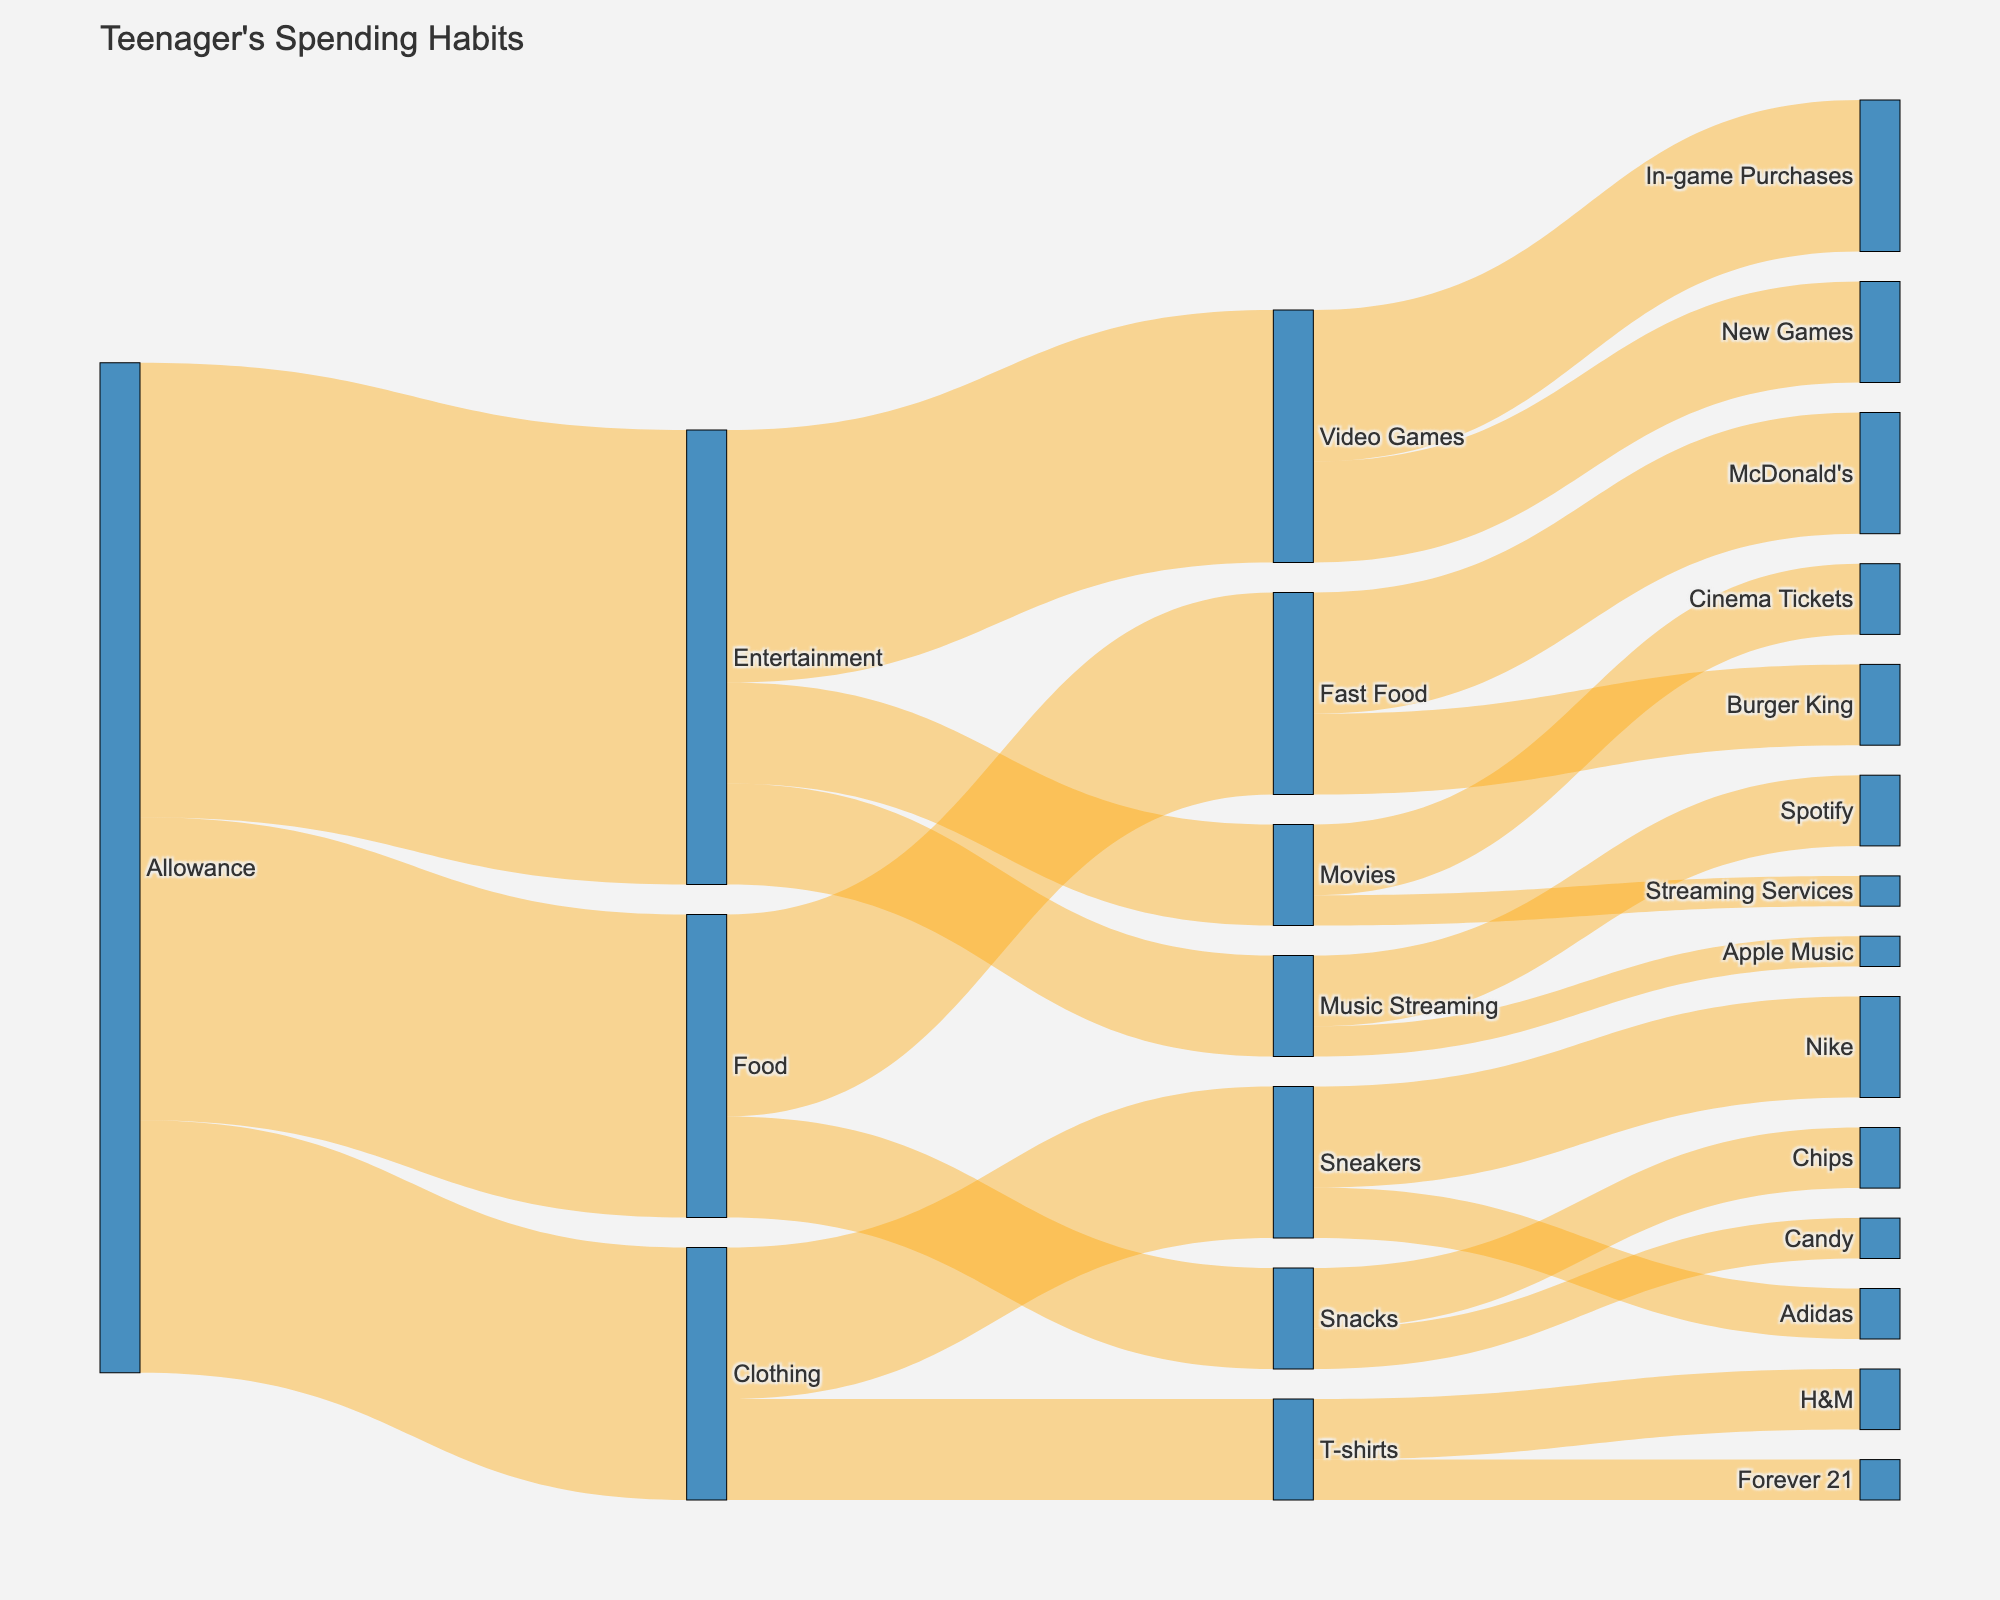what is the largest spending category for teenagers? The largest spending category for teenagers can be determined by the width of the flow connecting the "Allowance" node to the categories. The largest is "Entertainment" with a value of 45.
Answer: Entertainment how much do teenagers spend on video games? To find this, look at the flow from "Entertainment" to "Video Games," which has a value of 25.
Answer: 25 which fast food chain gets more money from teenagers, McDonald's or Burger King? Compare the widths of the flows from "Fast Food" to "McDonald's" and "Burger King." "McDonald's" has a value of 12 and "Burger King" has a value of 8.
Answer: McDonald's what is the total amount spent on music streaming services? The total amount is the sum of "Spotify" and "Apple Music." Adding 7 (Spotify) and 3 (Apple Music) gives 10.
Answer: 10 how much do teenagers spend in total on snacks? To find the total spent on snacks, look at the flows from "Snacks" to "Chips" and "Candy." Adding 6 (Chips) and 4 (Candy) gives 10.
Answer: 10 how does spending on t-shirts compare to spending on sneakers? Check the nodes for "Sneakers" and "T-shirts." "Sneakers" has a value of 15, and "T-shirts" has a value of 10.
Answer: Sneakers has more what is the most popular brand among teenagers for sneakers? Look at the flows from "Sneakers" to "Nike" and "Adidas." "Nike" has a value of 10, whereas "Adidas" has a value of 5.
Answer: Nike what's the least spent category for teenagers when it comes to clothing? Examine the flows within the "Clothing" category. The smallest flow is from "T-shirts" to "Forever 21" with a value of 4.
Answer: Forever 21 what's the total spending on food by teenagers? Add the values of "Fast Food" and "Snacks." "Fast Food" has 20 and "Snacks" has 10, summing up to 30.
Answer: 30 how does spending on cinema tickets compare to in-game purchases? Compare the values for "Cinema Tickets" (7) and "In-game Purchases" (15).
Answer: In-game purchases (15) is higher 